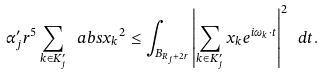Convert formula to latex. <formula><loc_0><loc_0><loc_500><loc_500>\alpha _ { j } ^ { \prime } r ^ { 5 } \sum _ { k \in K _ { j } ^ { \prime } } \ a b s { x _ { k } } ^ { 2 } \leq \int _ { B _ { R _ { j } + 2 r } } \left | \sum _ { k \in K _ { j } ^ { \prime } } x _ { k } e ^ { i \omega _ { k } \cdot t } \right | ^ { 2 } \ d t .</formula> 